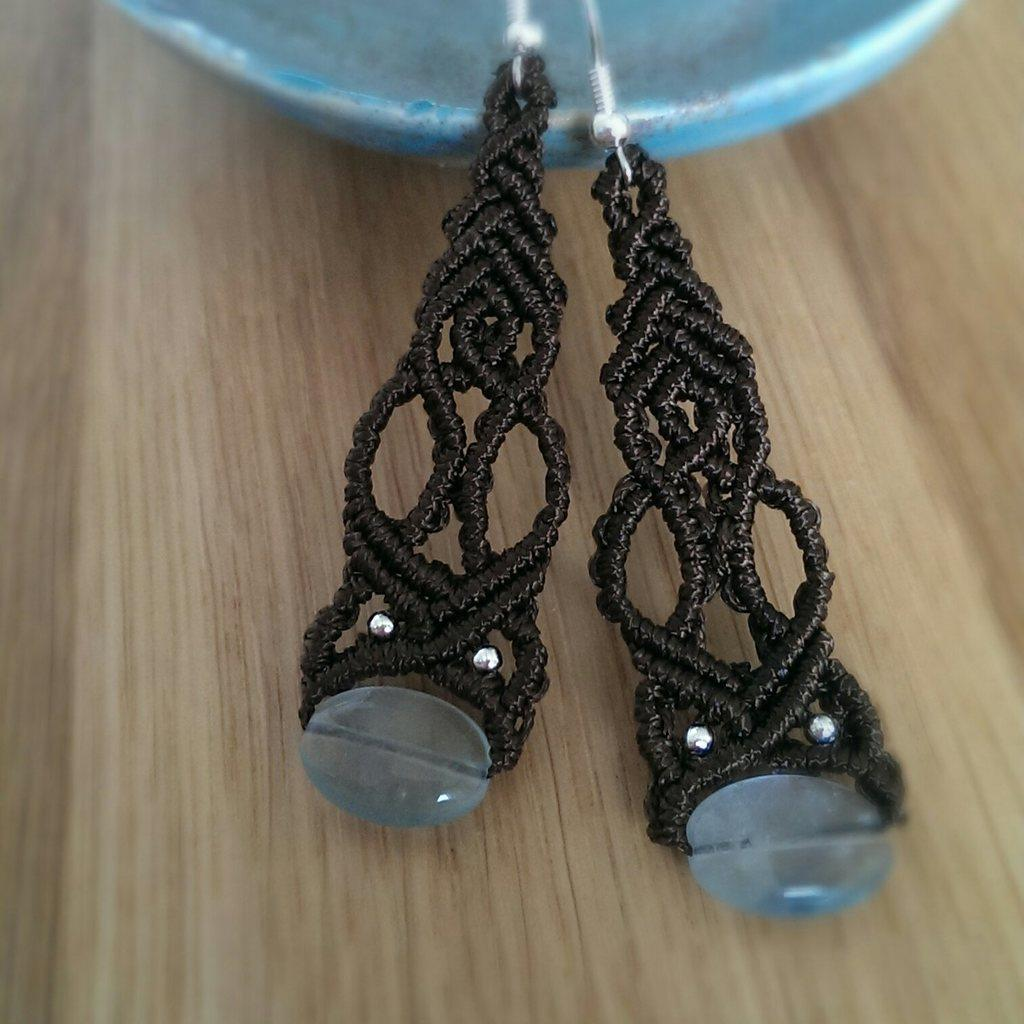What type of jewelry is on the wooden platform in the image? There are earrings on a wooden platform in the image. Can you describe the object at the top of the image? There is a blue color object at the top of the image. What type of thread is used to hold the jar in the image? There is no jar present in the image, so there is no thread holding it. What type of rod is supporting the earrings in the image? There is no rod present in the image; the earrings are on a wooden platform. 